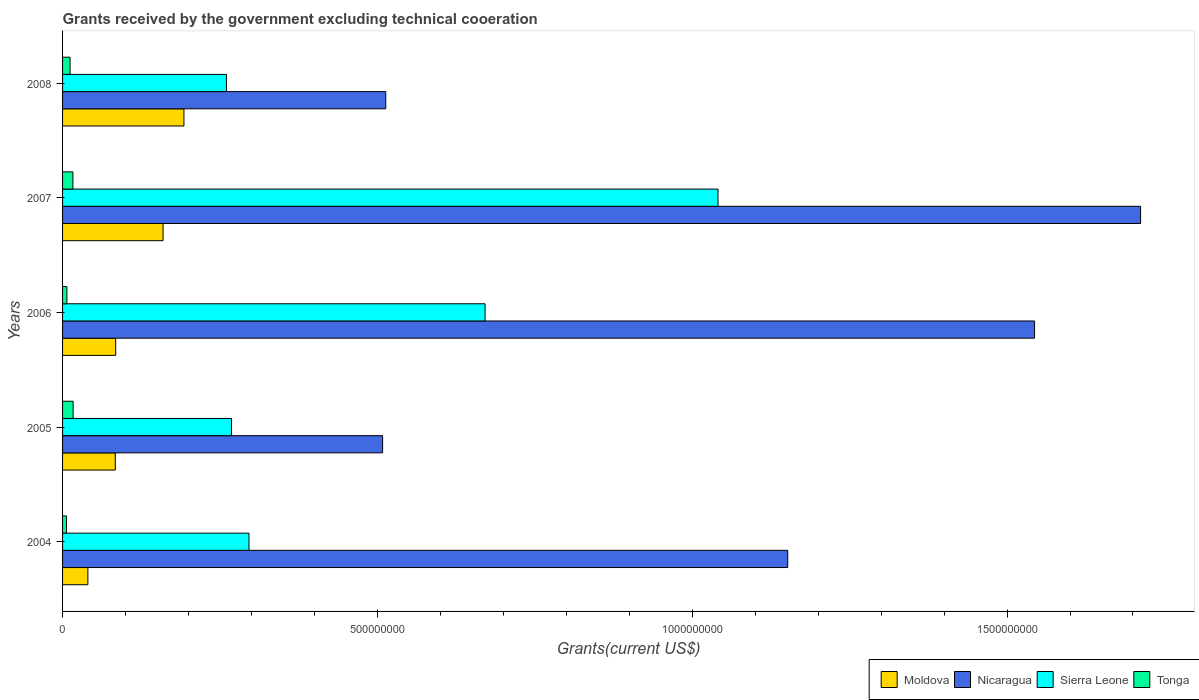How many different coloured bars are there?
Offer a terse response. 4. How many bars are there on the 4th tick from the top?
Provide a succinct answer. 4. What is the total grants received by the government in Moldova in 2004?
Ensure brevity in your answer.  4.02e+07. Across all years, what is the maximum total grants received by the government in Tonga?
Your answer should be compact. 1.68e+07. Across all years, what is the minimum total grants received by the government in Tonga?
Your response must be concise. 6.20e+06. What is the total total grants received by the government in Moldova in the graph?
Ensure brevity in your answer.  5.61e+08. What is the difference between the total grants received by the government in Sierra Leone in 2004 and that in 2005?
Make the answer very short. 2.78e+07. What is the difference between the total grants received by the government in Moldova in 2005 and the total grants received by the government in Sierra Leone in 2008?
Provide a short and direct response. -1.76e+08. What is the average total grants received by the government in Moldova per year?
Your answer should be compact. 1.12e+08. In the year 2008, what is the difference between the total grants received by the government in Nicaragua and total grants received by the government in Tonga?
Make the answer very short. 5.01e+08. What is the ratio of the total grants received by the government in Moldova in 2006 to that in 2008?
Provide a succinct answer. 0.44. Is the total grants received by the government in Nicaragua in 2004 less than that in 2006?
Keep it short and to the point. Yes. Is the difference between the total grants received by the government in Nicaragua in 2006 and 2007 greater than the difference between the total grants received by the government in Tonga in 2006 and 2007?
Provide a succinct answer. No. What is the difference between the highest and the second highest total grants received by the government in Nicaragua?
Make the answer very short. 1.68e+08. What is the difference between the highest and the lowest total grants received by the government in Nicaragua?
Offer a terse response. 1.20e+09. In how many years, is the total grants received by the government in Tonga greater than the average total grants received by the government in Tonga taken over all years?
Make the answer very short. 3. What does the 4th bar from the top in 2007 represents?
Make the answer very short. Moldova. What does the 4th bar from the bottom in 2007 represents?
Give a very brief answer. Tonga. Is it the case that in every year, the sum of the total grants received by the government in Tonga and total grants received by the government in Sierra Leone is greater than the total grants received by the government in Moldova?
Your answer should be compact. Yes. How many years are there in the graph?
Give a very brief answer. 5. What is the difference between two consecutive major ticks on the X-axis?
Keep it short and to the point. 5.00e+08. Does the graph contain any zero values?
Offer a very short reply. No. Does the graph contain grids?
Keep it short and to the point. No. Where does the legend appear in the graph?
Your response must be concise. Bottom right. How are the legend labels stacked?
Your answer should be very brief. Horizontal. What is the title of the graph?
Your answer should be very brief. Grants received by the government excluding technical cooeration. Does "Vanuatu" appear as one of the legend labels in the graph?
Provide a short and direct response. No. What is the label or title of the X-axis?
Your answer should be very brief. Grants(current US$). What is the label or title of the Y-axis?
Your response must be concise. Years. What is the Grants(current US$) of Moldova in 2004?
Provide a succinct answer. 4.02e+07. What is the Grants(current US$) in Nicaragua in 2004?
Provide a short and direct response. 1.15e+09. What is the Grants(current US$) of Sierra Leone in 2004?
Keep it short and to the point. 2.96e+08. What is the Grants(current US$) in Tonga in 2004?
Ensure brevity in your answer.  6.20e+06. What is the Grants(current US$) of Moldova in 2005?
Ensure brevity in your answer.  8.38e+07. What is the Grants(current US$) in Nicaragua in 2005?
Provide a succinct answer. 5.08e+08. What is the Grants(current US$) in Sierra Leone in 2005?
Provide a short and direct response. 2.68e+08. What is the Grants(current US$) in Tonga in 2005?
Ensure brevity in your answer.  1.68e+07. What is the Grants(current US$) of Moldova in 2006?
Keep it short and to the point. 8.44e+07. What is the Grants(current US$) of Nicaragua in 2006?
Your answer should be very brief. 1.54e+09. What is the Grants(current US$) of Sierra Leone in 2006?
Offer a very short reply. 6.71e+08. What is the Grants(current US$) in Tonga in 2006?
Your answer should be compact. 6.88e+06. What is the Grants(current US$) in Moldova in 2007?
Offer a very short reply. 1.60e+08. What is the Grants(current US$) of Nicaragua in 2007?
Keep it short and to the point. 1.71e+09. What is the Grants(current US$) of Sierra Leone in 2007?
Offer a terse response. 1.04e+09. What is the Grants(current US$) of Tonga in 2007?
Ensure brevity in your answer.  1.64e+07. What is the Grants(current US$) in Moldova in 2008?
Provide a succinct answer. 1.93e+08. What is the Grants(current US$) of Nicaragua in 2008?
Your answer should be compact. 5.13e+08. What is the Grants(current US$) in Sierra Leone in 2008?
Make the answer very short. 2.60e+08. What is the Grants(current US$) in Tonga in 2008?
Give a very brief answer. 1.19e+07. Across all years, what is the maximum Grants(current US$) in Moldova?
Provide a short and direct response. 1.93e+08. Across all years, what is the maximum Grants(current US$) in Nicaragua?
Your response must be concise. 1.71e+09. Across all years, what is the maximum Grants(current US$) in Sierra Leone?
Your answer should be very brief. 1.04e+09. Across all years, what is the maximum Grants(current US$) of Tonga?
Your answer should be compact. 1.68e+07. Across all years, what is the minimum Grants(current US$) in Moldova?
Make the answer very short. 4.02e+07. Across all years, what is the minimum Grants(current US$) of Nicaragua?
Ensure brevity in your answer.  5.08e+08. Across all years, what is the minimum Grants(current US$) of Sierra Leone?
Offer a terse response. 2.60e+08. Across all years, what is the minimum Grants(current US$) in Tonga?
Keep it short and to the point. 6.20e+06. What is the total Grants(current US$) of Moldova in the graph?
Your answer should be compact. 5.61e+08. What is the total Grants(current US$) in Nicaragua in the graph?
Provide a short and direct response. 5.43e+09. What is the total Grants(current US$) of Sierra Leone in the graph?
Offer a very short reply. 2.54e+09. What is the total Grants(current US$) of Tonga in the graph?
Provide a short and direct response. 5.82e+07. What is the difference between the Grants(current US$) of Moldova in 2004 and that in 2005?
Provide a succinct answer. -4.36e+07. What is the difference between the Grants(current US$) in Nicaragua in 2004 and that in 2005?
Make the answer very short. 6.43e+08. What is the difference between the Grants(current US$) in Sierra Leone in 2004 and that in 2005?
Keep it short and to the point. 2.78e+07. What is the difference between the Grants(current US$) of Tonga in 2004 and that in 2005?
Make the answer very short. -1.06e+07. What is the difference between the Grants(current US$) of Moldova in 2004 and that in 2006?
Ensure brevity in your answer.  -4.42e+07. What is the difference between the Grants(current US$) of Nicaragua in 2004 and that in 2006?
Your answer should be very brief. -3.92e+08. What is the difference between the Grants(current US$) in Sierra Leone in 2004 and that in 2006?
Provide a short and direct response. -3.75e+08. What is the difference between the Grants(current US$) of Tonga in 2004 and that in 2006?
Ensure brevity in your answer.  -6.80e+05. What is the difference between the Grants(current US$) of Moldova in 2004 and that in 2007?
Offer a very short reply. -1.19e+08. What is the difference between the Grants(current US$) of Nicaragua in 2004 and that in 2007?
Keep it short and to the point. -5.60e+08. What is the difference between the Grants(current US$) in Sierra Leone in 2004 and that in 2007?
Provide a succinct answer. -7.45e+08. What is the difference between the Grants(current US$) in Tonga in 2004 and that in 2007?
Offer a terse response. -1.02e+07. What is the difference between the Grants(current US$) of Moldova in 2004 and that in 2008?
Give a very brief answer. -1.53e+08. What is the difference between the Grants(current US$) of Nicaragua in 2004 and that in 2008?
Your answer should be compact. 6.38e+08. What is the difference between the Grants(current US$) of Sierra Leone in 2004 and that in 2008?
Give a very brief answer. 3.58e+07. What is the difference between the Grants(current US$) in Tonga in 2004 and that in 2008?
Your answer should be compact. -5.71e+06. What is the difference between the Grants(current US$) in Moldova in 2005 and that in 2006?
Provide a succinct answer. -5.70e+05. What is the difference between the Grants(current US$) in Nicaragua in 2005 and that in 2006?
Make the answer very short. -1.04e+09. What is the difference between the Grants(current US$) of Sierra Leone in 2005 and that in 2006?
Give a very brief answer. -4.03e+08. What is the difference between the Grants(current US$) in Tonga in 2005 and that in 2006?
Keep it short and to the point. 9.90e+06. What is the difference between the Grants(current US$) of Moldova in 2005 and that in 2007?
Your answer should be compact. -7.58e+07. What is the difference between the Grants(current US$) of Nicaragua in 2005 and that in 2007?
Give a very brief answer. -1.20e+09. What is the difference between the Grants(current US$) of Sierra Leone in 2005 and that in 2007?
Make the answer very short. -7.73e+08. What is the difference between the Grants(current US$) of Tonga in 2005 and that in 2007?
Keep it short and to the point. 3.50e+05. What is the difference between the Grants(current US$) in Moldova in 2005 and that in 2008?
Keep it short and to the point. -1.09e+08. What is the difference between the Grants(current US$) in Nicaragua in 2005 and that in 2008?
Ensure brevity in your answer.  -4.98e+06. What is the difference between the Grants(current US$) of Sierra Leone in 2005 and that in 2008?
Your answer should be compact. 7.96e+06. What is the difference between the Grants(current US$) of Tonga in 2005 and that in 2008?
Keep it short and to the point. 4.87e+06. What is the difference between the Grants(current US$) of Moldova in 2006 and that in 2007?
Your answer should be compact. -7.52e+07. What is the difference between the Grants(current US$) in Nicaragua in 2006 and that in 2007?
Offer a very short reply. -1.68e+08. What is the difference between the Grants(current US$) of Sierra Leone in 2006 and that in 2007?
Offer a very short reply. -3.70e+08. What is the difference between the Grants(current US$) of Tonga in 2006 and that in 2007?
Your answer should be compact. -9.55e+06. What is the difference between the Grants(current US$) in Moldova in 2006 and that in 2008?
Make the answer very short. -1.08e+08. What is the difference between the Grants(current US$) of Nicaragua in 2006 and that in 2008?
Your answer should be compact. 1.03e+09. What is the difference between the Grants(current US$) of Sierra Leone in 2006 and that in 2008?
Your answer should be very brief. 4.11e+08. What is the difference between the Grants(current US$) of Tonga in 2006 and that in 2008?
Offer a terse response. -5.03e+06. What is the difference between the Grants(current US$) of Moldova in 2007 and that in 2008?
Offer a very short reply. -3.32e+07. What is the difference between the Grants(current US$) of Nicaragua in 2007 and that in 2008?
Provide a succinct answer. 1.20e+09. What is the difference between the Grants(current US$) in Sierra Leone in 2007 and that in 2008?
Provide a short and direct response. 7.81e+08. What is the difference between the Grants(current US$) in Tonga in 2007 and that in 2008?
Keep it short and to the point. 4.52e+06. What is the difference between the Grants(current US$) in Moldova in 2004 and the Grants(current US$) in Nicaragua in 2005?
Offer a terse response. -4.68e+08. What is the difference between the Grants(current US$) in Moldova in 2004 and the Grants(current US$) in Sierra Leone in 2005?
Offer a terse response. -2.28e+08. What is the difference between the Grants(current US$) in Moldova in 2004 and the Grants(current US$) in Tonga in 2005?
Provide a short and direct response. 2.34e+07. What is the difference between the Grants(current US$) of Nicaragua in 2004 and the Grants(current US$) of Sierra Leone in 2005?
Offer a terse response. 8.83e+08. What is the difference between the Grants(current US$) in Nicaragua in 2004 and the Grants(current US$) in Tonga in 2005?
Provide a succinct answer. 1.13e+09. What is the difference between the Grants(current US$) in Sierra Leone in 2004 and the Grants(current US$) in Tonga in 2005?
Ensure brevity in your answer.  2.79e+08. What is the difference between the Grants(current US$) in Moldova in 2004 and the Grants(current US$) in Nicaragua in 2006?
Offer a very short reply. -1.50e+09. What is the difference between the Grants(current US$) of Moldova in 2004 and the Grants(current US$) of Sierra Leone in 2006?
Offer a very short reply. -6.31e+08. What is the difference between the Grants(current US$) of Moldova in 2004 and the Grants(current US$) of Tonga in 2006?
Offer a very short reply. 3.33e+07. What is the difference between the Grants(current US$) in Nicaragua in 2004 and the Grants(current US$) in Sierra Leone in 2006?
Provide a short and direct response. 4.81e+08. What is the difference between the Grants(current US$) in Nicaragua in 2004 and the Grants(current US$) in Tonga in 2006?
Provide a succinct answer. 1.14e+09. What is the difference between the Grants(current US$) of Sierra Leone in 2004 and the Grants(current US$) of Tonga in 2006?
Give a very brief answer. 2.89e+08. What is the difference between the Grants(current US$) of Moldova in 2004 and the Grants(current US$) of Nicaragua in 2007?
Your answer should be compact. -1.67e+09. What is the difference between the Grants(current US$) of Moldova in 2004 and the Grants(current US$) of Sierra Leone in 2007?
Offer a terse response. -1.00e+09. What is the difference between the Grants(current US$) in Moldova in 2004 and the Grants(current US$) in Tonga in 2007?
Make the answer very short. 2.38e+07. What is the difference between the Grants(current US$) in Nicaragua in 2004 and the Grants(current US$) in Sierra Leone in 2007?
Your answer should be very brief. 1.11e+08. What is the difference between the Grants(current US$) of Nicaragua in 2004 and the Grants(current US$) of Tonga in 2007?
Provide a short and direct response. 1.14e+09. What is the difference between the Grants(current US$) in Sierra Leone in 2004 and the Grants(current US$) in Tonga in 2007?
Your answer should be compact. 2.80e+08. What is the difference between the Grants(current US$) of Moldova in 2004 and the Grants(current US$) of Nicaragua in 2008?
Give a very brief answer. -4.73e+08. What is the difference between the Grants(current US$) in Moldova in 2004 and the Grants(current US$) in Sierra Leone in 2008?
Make the answer very short. -2.20e+08. What is the difference between the Grants(current US$) of Moldova in 2004 and the Grants(current US$) of Tonga in 2008?
Your answer should be very brief. 2.83e+07. What is the difference between the Grants(current US$) of Nicaragua in 2004 and the Grants(current US$) of Sierra Leone in 2008?
Ensure brevity in your answer.  8.91e+08. What is the difference between the Grants(current US$) of Nicaragua in 2004 and the Grants(current US$) of Tonga in 2008?
Offer a very short reply. 1.14e+09. What is the difference between the Grants(current US$) of Sierra Leone in 2004 and the Grants(current US$) of Tonga in 2008?
Give a very brief answer. 2.84e+08. What is the difference between the Grants(current US$) in Moldova in 2005 and the Grants(current US$) in Nicaragua in 2006?
Provide a short and direct response. -1.46e+09. What is the difference between the Grants(current US$) of Moldova in 2005 and the Grants(current US$) of Sierra Leone in 2006?
Make the answer very short. -5.87e+08. What is the difference between the Grants(current US$) in Moldova in 2005 and the Grants(current US$) in Tonga in 2006?
Your response must be concise. 7.69e+07. What is the difference between the Grants(current US$) of Nicaragua in 2005 and the Grants(current US$) of Sierra Leone in 2006?
Keep it short and to the point. -1.63e+08. What is the difference between the Grants(current US$) of Nicaragua in 2005 and the Grants(current US$) of Tonga in 2006?
Your answer should be compact. 5.01e+08. What is the difference between the Grants(current US$) in Sierra Leone in 2005 and the Grants(current US$) in Tonga in 2006?
Your answer should be very brief. 2.61e+08. What is the difference between the Grants(current US$) of Moldova in 2005 and the Grants(current US$) of Nicaragua in 2007?
Offer a terse response. -1.63e+09. What is the difference between the Grants(current US$) of Moldova in 2005 and the Grants(current US$) of Sierra Leone in 2007?
Make the answer very short. -9.57e+08. What is the difference between the Grants(current US$) in Moldova in 2005 and the Grants(current US$) in Tonga in 2007?
Make the answer very short. 6.74e+07. What is the difference between the Grants(current US$) in Nicaragua in 2005 and the Grants(current US$) in Sierra Leone in 2007?
Your response must be concise. -5.33e+08. What is the difference between the Grants(current US$) of Nicaragua in 2005 and the Grants(current US$) of Tonga in 2007?
Your answer should be very brief. 4.92e+08. What is the difference between the Grants(current US$) of Sierra Leone in 2005 and the Grants(current US$) of Tonga in 2007?
Your answer should be compact. 2.52e+08. What is the difference between the Grants(current US$) of Moldova in 2005 and the Grants(current US$) of Nicaragua in 2008?
Your answer should be very brief. -4.29e+08. What is the difference between the Grants(current US$) in Moldova in 2005 and the Grants(current US$) in Sierra Leone in 2008?
Give a very brief answer. -1.76e+08. What is the difference between the Grants(current US$) of Moldova in 2005 and the Grants(current US$) of Tonga in 2008?
Your answer should be compact. 7.19e+07. What is the difference between the Grants(current US$) of Nicaragua in 2005 and the Grants(current US$) of Sierra Leone in 2008?
Your response must be concise. 2.48e+08. What is the difference between the Grants(current US$) in Nicaragua in 2005 and the Grants(current US$) in Tonga in 2008?
Give a very brief answer. 4.96e+08. What is the difference between the Grants(current US$) in Sierra Leone in 2005 and the Grants(current US$) in Tonga in 2008?
Provide a short and direct response. 2.56e+08. What is the difference between the Grants(current US$) in Moldova in 2006 and the Grants(current US$) in Nicaragua in 2007?
Offer a very short reply. -1.63e+09. What is the difference between the Grants(current US$) of Moldova in 2006 and the Grants(current US$) of Sierra Leone in 2007?
Your answer should be very brief. -9.57e+08. What is the difference between the Grants(current US$) in Moldova in 2006 and the Grants(current US$) in Tonga in 2007?
Keep it short and to the point. 6.79e+07. What is the difference between the Grants(current US$) in Nicaragua in 2006 and the Grants(current US$) in Sierra Leone in 2007?
Your answer should be very brief. 5.03e+08. What is the difference between the Grants(current US$) in Nicaragua in 2006 and the Grants(current US$) in Tonga in 2007?
Offer a terse response. 1.53e+09. What is the difference between the Grants(current US$) of Sierra Leone in 2006 and the Grants(current US$) of Tonga in 2007?
Give a very brief answer. 6.55e+08. What is the difference between the Grants(current US$) of Moldova in 2006 and the Grants(current US$) of Nicaragua in 2008?
Your answer should be compact. -4.29e+08. What is the difference between the Grants(current US$) in Moldova in 2006 and the Grants(current US$) in Sierra Leone in 2008?
Keep it short and to the point. -1.76e+08. What is the difference between the Grants(current US$) of Moldova in 2006 and the Grants(current US$) of Tonga in 2008?
Provide a succinct answer. 7.24e+07. What is the difference between the Grants(current US$) of Nicaragua in 2006 and the Grants(current US$) of Sierra Leone in 2008?
Offer a terse response. 1.28e+09. What is the difference between the Grants(current US$) of Nicaragua in 2006 and the Grants(current US$) of Tonga in 2008?
Provide a short and direct response. 1.53e+09. What is the difference between the Grants(current US$) in Sierra Leone in 2006 and the Grants(current US$) in Tonga in 2008?
Keep it short and to the point. 6.59e+08. What is the difference between the Grants(current US$) in Moldova in 2007 and the Grants(current US$) in Nicaragua in 2008?
Your response must be concise. -3.54e+08. What is the difference between the Grants(current US$) of Moldova in 2007 and the Grants(current US$) of Sierra Leone in 2008?
Your answer should be compact. -1.01e+08. What is the difference between the Grants(current US$) of Moldova in 2007 and the Grants(current US$) of Tonga in 2008?
Your answer should be very brief. 1.48e+08. What is the difference between the Grants(current US$) in Nicaragua in 2007 and the Grants(current US$) in Sierra Leone in 2008?
Make the answer very short. 1.45e+09. What is the difference between the Grants(current US$) in Nicaragua in 2007 and the Grants(current US$) in Tonga in 2008?
Your answer should be very brief. 1.70e+09. What is the difference between the Grants(current US$) of Sierra Leone in 2007 and the Grants(current US$) of Tonga in 2008?
Provide a short and direct response. 1.03e+09. What is the average Grants(current US$) in Moldova per year?
Provide a short and direct response. 1.12e+08. What is the average Grants(current US$) of Nicaragua per year?
Your answer should be very brief. 1.09e+09. What is the average Grants(current US$) in Sierra Leone per year?
Your answer should be very brief. 5.07e+08. What is the average Grants(current US$) of Tonga per year?
Give a very brief answer. 1.16e+07. In the year 2004, what is the difference between the Grants(current US$) of Moldova and Grants(current US$) of Nicaragua?
Offer a terse response. -1.11e+09. In the year 2004, what is the difference between the Grants(current US$) of Moldova and Grants(current US$) of Sierra Leone?
Ensure brevity in your answer.  -2.56e+08. In the year 2004, what is the difference between the Grants(current US$) of Moldova and Grants(current US$) of Tonga?
Ensure brevity in your answer.  3.40e+07. In the year 2004, what is the difference between the Grants(current US$) in Nicaragua and Grants(current US$) in Sierra Leone?
Provide a succinct answer. 8.56e+08. In the year 2004, what is the difference between the Grants(current US$) in Nicaragua and Grants(current US$) in Tonga?
Offer a very short reply. 1.15e+09. In the year 2004, what is the difference between the Grants(current US$) of Sierra Leone and Grants(current US$) of Tonga?
Make the answer very short. 2.90e+08. In the year 2005, what is the difference between the Grants(current US$) in Moldova and Grants(current US$) in Nicaragua?
Your answer should be very brief. -4.24e+08. In the year 2005, what is the difference between the Grants(current US$) in Moldova and Grants(current US$) in Sierra Leone?
Give a very brief answer. -1.84e+08. In the year 2005, what is the difference between the Grants(current US$) in Moldova and Grants(current US$) in Tonga?
Offer a terse response. 6.70e+07. In the year 2005, what is the difference between the Grants(current US$) in Nicaragua and Grants(current US$) in Sierra Leone?
Provide a short and direct response. 2.40e+08. In the year 2005, what is the difference between the Grants(current US$) in Nicaragua and Grants(current US$) in Tonga?
Keep it short and to the point. 4.92e+08. In the year 2005, what is the difference between the Grants(current US$) of Sierra Leone and Grants(current US$) of Tonga?
Offer a very short reply. 2.51e+08. In the year 2006, what is the difference between the Grants(current US$) in Moldova and Grants(current US$) in Nicaragua?
Make the answer very short. -1.46e+09. In the year 2006, what is the difference between the Grants(current US$) in Moldova and Grants(current US$) in Sierra Leone?
Offer a very short reply. -5.87e+08. In the year 2006, what is the difference between the Grants(current US$) of Moldova and Grants(current US$) of Tonga?
Give a very brief answer. 7.75e+07. In the year 2006, what is the difference between the Grants(current US$) of Nicaragua and Grants(current US$) of Sierra Leone?
Your answer should be very brief. 8.73e+08. In the year 2006, what is the difference between the Grants(current US$) of Nicaragua and Grants(current US$) of Tonga?
Your answer should be compact. 1.54e+09. In the year 2006, what is the difference between the Grants(current US$) in Sierra Leone and Grants(current US$) in Tonga?
Give a very brief answer. 6.64e+08. In the year 2007, what is the difference between the Grants(current US$) in Moldova and Grants(current US$) in Nicaragua?
Your answer should be compact. -1.55e+09. In the year 2007, what is the difference between the Grants(current US$) in Moldova and Grants(current US$) in Sierra Leone?
Provide a succinct answer. -8.81e+08. In the year 2007, what is the difference between the Grants(current US$) in Moldova and Grants(current US$) in Tonga?
Give a very brief answer. 1.43e+08. In the year 2007, what is the difference between the Grants(current US$) in Nicaragua and Grants(current US$) in Sierra Leone?
Provide a succinct answer. 6.71e+08. In the year 2007, what is the difference between the Grants(current US$) of Nicaragua and Grants(current US$) of Tonga?
Keep it short and to the point. 1.70e+09. In the year 2007, what is the difference between the Grants(current US$) of Sierra Leone and Grants(current US$) of Tonga?
Your answer should be very brief. 1.02e+09. In the year 2008, what is the difference between the Grants(current US$) in Moldova and Grants(current US$) in Nicaragua?
Provide a succinct answer. -3.20e+08. In the year 2008, what is the difference between the Grants(current US$) in Moldova and Grants(current US$) in Sierra Leone?
Keep it short and to the point. -6.75e+07. In the year 2008, what is the difference between the Grants(current US$) of Moldova and Grants(current US$) of Tonga?
Give a very brief answer. 1.81e+08. In the year 2008, what is the difference between the Grants(current US$) of Nicaragua and Grants(current US$) of Sierra Leone?
Provide a succinct answer. 2.53e+08. In the year 2008, what is the difference between the Grants(current US$) of Nicaragua and Grants(current US$) of Tonga?
Give a very brief answer. 5.01e+08. In the year 2008, what is the difference between the Grants(current US$) in Sierra Leone and Grants(current US$) in Tonga?
Ensure brevity in your answer.  2.48e+08. What is the ratio of the Grants(current US$) of Moldova in 2004 to that in 2005?
Ensure brevity in your answer.  0.48. What is the ratio of the Grants(current US$) of Nicaragua in 2004 to that in 2005?
Offer a very short reply. 2.27. What is the ratio of the Grants(current US$) of Sierra Leone in 2004 to that in 2005?
Keep it short and to the point. 1.1. What is the ratio of the Grants(current US$) in Tonga in 2004 to that in 2005?
Keep it short and to the point. 0.37. What is the ratio of the Grants(current US$) of Moldova in 2004 to that in 2006?
Your answer should be compact. 0.48. What is the ratio of the Grants(current US$) of Nicaragua in 2004 to that in 2006?
Give a very brief answer. 0.75. What is the ratio of the Grants(current US$) in Sierra Leone in 2004 to that in 2006?
Provide a succinct answer. 0.44. What is the ratio of the Grants(current US$) of Tonga in 2004 to that in 2006?
Your answer should be compact. 0.9. What is the ratio of the Grants(current US$) of Moldova in 2004 to that in 2007?
Provide a succinct answer. 0.25. What is the ratio of the Grants(current US$) of Nicaragua in 2004 to that in 2007?
Your response must be concise. 0.67. What is the ratio of the Grants(current US$) of Sierra Leone in 2004 to that in 2007?
Offer a terse response. 0.28. What is the ratio of the Grants(current US$) in Tonga in 2004 to that in 2007?
Your response must be concise. 0.38. What is the ratio of the Grants(current US$) of Moldova in 2004 to that in 2008?
Your answer should be very brief. 0.21. What is the ratio of the Grants(current US$) in Nicaragua in 2004 to that in 2008?
Ensure brevity in your answer.  2.24. What is the ratio of the Grants(current US$) in Sierra Leone in 2004 to that in 2008?
Provide a succinct answer. 1.14. What is the ratio of the Grants(current US$) of Tonga in 2004 to that in 2008?
Keep it short and to the point. 0.52. What is the ratio of the Grants(current US$) in Nicaragua in 2005 to that in 2006?
Your answer should be very brief. 0.33. What is the ratio of the Grants(current US$) in Sierra Leone in 2005 to that in 2006?
Offer a very short reply. 0.4. What is the ratio of the Grants(current US$) in Tonga in 2005 to that in 2006?
Keep it short and to the point. 2.44. What is the ratio of the Grants(current US$) of Moldova in 2005 to that in 2007?
Make the answer very short. 0.53. What is the ratio of the Grants(current US$) of Nicaragua in 2005 to that in 2007?
Your answer should be compact. 0.3. What is the ratio of the Grants(current US$) in Sierra Leone in 2005 to that in 2007?
Provide a short and direct response. 0.26. What is the ratio of the Grants(current US$) in Tonga in 2005 to that in 2007?
Give a very brief answer. 1.02. What is the ratio of the Grants(current US$) of Moldova in 2005 to that in 2008?
Your answer should be very brief. 0.43. What is the ratio of the Grants(current US$) of Nicaragua in 2005 to that in 2008?
Ensure brevity in your answer.  0.99. What is the ratio of the Grants(current US$) of Sierra Leone in 2005 to that in 2008?
Give a very brief answer. 1.03. What is the ratio of the Grants(current US$) in Tonga in 2005 to that in 2008?
Your answer should be compact. 1.41. What is the ratio of the Grants(current US$) in Moldova in 2006 to that in 2007?
Ensure brevity in your answer.  0.53. What is the ratio of the Grants(current US$) of Nicaragua in 2006 to that in 2007?
Provide a short and direct response. 0.9. What is the ratio of the Grants(current US$) of Sierra Leone in 2006 to that in 2007?
Your response must be concise. 0.64. What is the ratio of the Grants(current US$) in Tonga in 2006 to that in 2007?
Your response must be concise. 0.42. What is the ratio of the Grants(current US$) of Moldova in 2006 to that in 2008?
Your answer should be compact. 0.44. What is the ratio of the Grants(current US$) of Nicaragua in 2006 to that in 2008?
Provide a short and direct response. 3.01. What is the ratio of the Grants(current US$) of Sierra Leone in 2006 to that in 2008?
Your answer should be compact. 2.58. What is the ratio of the Grants(current US$) in Tonga in 2006 to that in 2008?
Ensure brevity in your answer.  0.58. What is the ratio of the Grants(current US$) of Moldova in 2007 to that in 2008?
Make the answer very short. 0.83. What is the ratio of the Grants(current US$) of Nicaragua in 2007 to that in 2008?
Offer a terse response. 3.34. What is the ratio of the Grants(current US$) in Sierra Leone in 2007 to that in 2008?
Provide a succinct answer. 4. What is the ratio of the Grants(current US$) in Tonga in 2007 to that in 2008?
Offer a terse response. 1.38. What is the difference between the highest and the second highest Grants(current US$) in Moldova?
Provide a short and direct response. 3.32e+07. What is the difference between the highest and the second highest Grants(current US$) in Nicaragua?
Provide a short and direct response. 1.68e+08. What is the difference between the highest and the second highest Grants(current US$) in Sierra Leone?
Offer a very short reply. 3.70e+08. What is the difference between the highest and the second highest Grants(current US$) of Tonga?
Make the answer very short. 3.50e+05. What is the difference between the highest and the lowest Grants(current US$) in Moldova?
Provide a short and direct response. 1.53e+08. What is the difference between the highest and the lowest Grants(current US$) of Nicaragua?
Make the answer very short. 1.20e+09. What is the difference between the highest and the lowest Grants(current US$) of Sierra Leone?
Provide a short and direct response. 7.81e+08. What is the difference between the highest and the lowest Grants(current US$) of Tonga?
Offer a very short reply. 1.06e+07. 